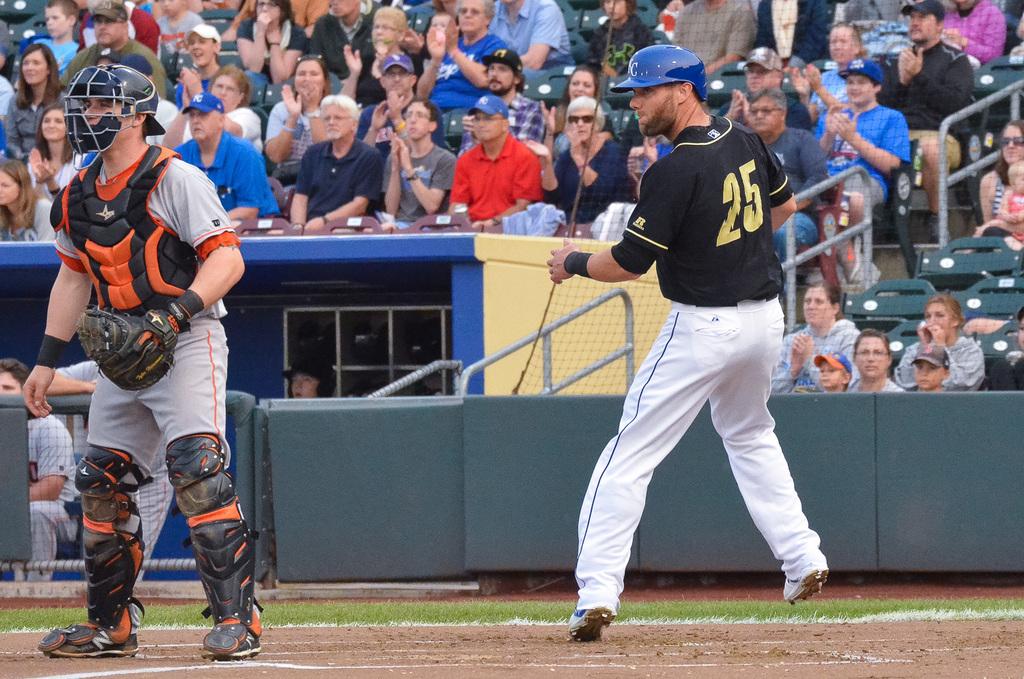What number is the runner?
Ensure brevity in your answer.  25. 